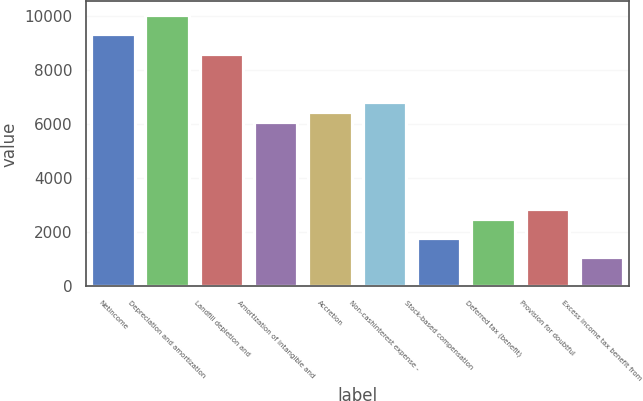<chart> <loc_0><loc_0><loc_500><loc_500><bar_chart><fcel>Netincome<fcel>Depreciation and amortization<fcel>Landfill depletion and<fcel>Amortization of intangible and<fcel>Accretion<fcel>Non-cashinterest expense -<fcel>Stock-based compensation<fcel>Deferred tax (benefit)<fcel>Provision for doubtful<fcel>Excess income tax benefit from<nl><fcel>9317.98<fcel>10034.7<fcel>8601.22<fcel>6092.56<fcel>6450.94<fcel>6809.32<fcel>1792<fcel>2508.76<fcel>2867.14<fcel>1075.24<nl></chart> 